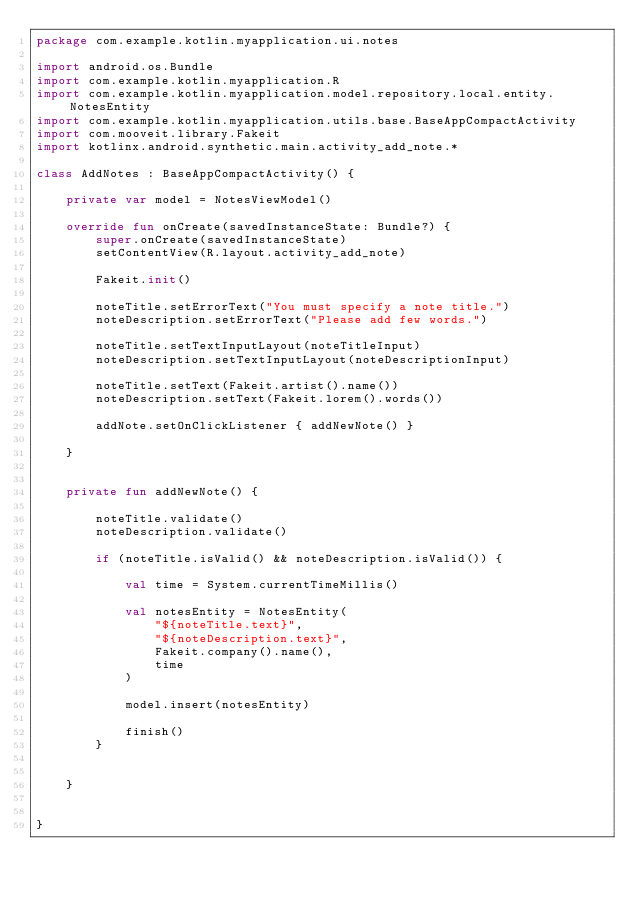<code> <loc_0><loc_0><loc_500><loc_500><_Kotlin_>package com.example.kotlin.myapplication.ui.notes

import android.os.Bundle
import com.example.kotlin.myapplication.R
import com.example.kotlin.myapplication.model.repository.local.entity.NotesEntity
import com.example.kotlin.myapplication.utils.base.BaseAppCompactActivity
import com.mooveit.library.Fakeit
import kotlinx.android.synthetic.main.activity_add_note.*

class AddNotes : BaseAppCompactActivity() {

    private var model = NotesViewModel()

    override fun onCreate(savedInstanceState: Bundle?) {
        super.onCreate(savedInstanceState)
        setContentView(R.layout.activity_add_note)

        Fakeit.init()

        noteTitle.setErrorText("You must specify a note title.")
        noteDescription.setErrorText("Please add few words.")

        noteTitle.setTextInputLayout(noteTitleInput)
        noteDescription.setTextInputLayout(noteDescriptionInput)

        noteTitle.setText(Fakeit.artist().name())
        noteDescription.setText(Fakeit.lorem().words())

        addNote.setOnClickListener { addNewNote() }

    }


    private fun addNewNote() {

        noteTitle.validate()
        noteDescription.validate()

        if (noteTitle.isValid() && noteDescription.isValid()) {

            val time = System.currentTimeMillis()

            val notesEntity = NotesEntity(
                "${noteTitle.text}",
                "${noteDescription.text}",
                Fakeit.company().name(),
                time
            )

            model.insert(notesEntity)

            finish()
        }


    }


}</code> 